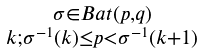<formula> <loc_0><loc_0><loc_500><loc_500>\begin{smallmatrix} \sigma \in B a t ( p , q ) \\ k ; \sigma ^ { - 1 } ( k ) \leq p < \sigma ^ { - 1 } ( k + 1 ) \end{smallmatrix}</formula> 